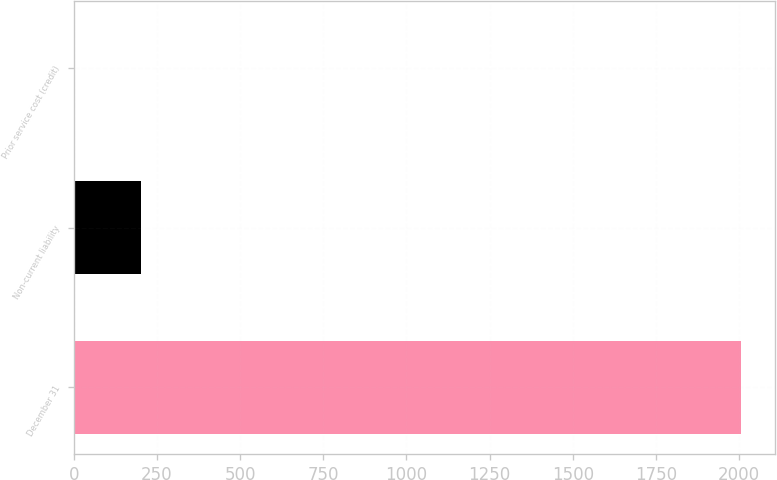Convert chart to OTSL. <chart><loc_0><loc_0><loc_500><loc_500><bar_chart><fcel>December 31<fcel>Non-current liability<fcel>Prior service cost (credit)<nl><fcel>2006<fcel>200.78<fcel>0.2<nl></chart> 